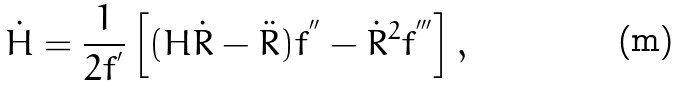<formula> <loc_0><loc_0><loc_500><loc_500>\dot { H } = \frac { 1 } { 2 f ^ { ^ { \prime } } } \left [ ( H \dot { R } - \ddot { R } ) f ^ { ^ { \prime \prime } } - \dot { R } ^ { 2 } f ^ { ^ { \prime \prime \prime } } \right ] ,</formula> 